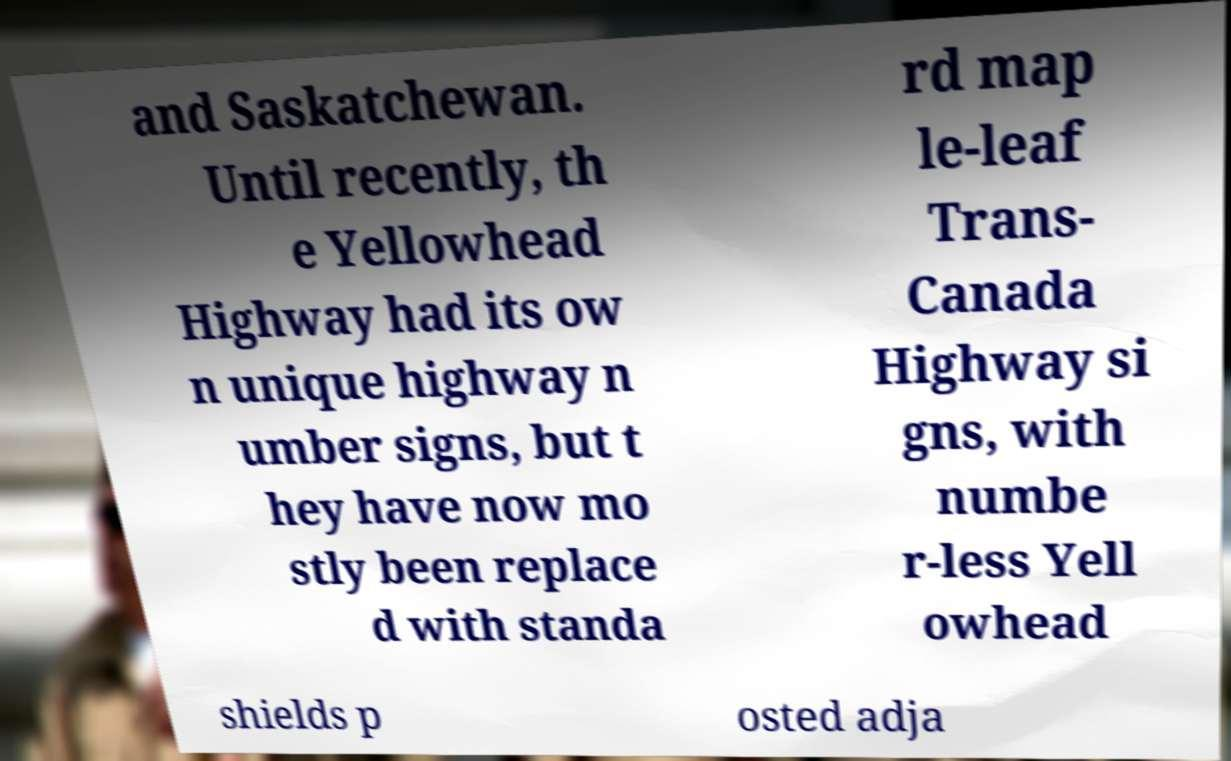Can you read and provide the text displayed in the image?This photo seems to have some interesting text. Can you extract and type it out for me? and Saskatchewan. Until recently, th e Yellowhead Highway had its ow n unique highway n umber signs, but t hey have now mo stly been replace d with standa rd map le-leaf Trans- Canada Highway si gns, with numbe r-less Yell owhead shields p osted adja 